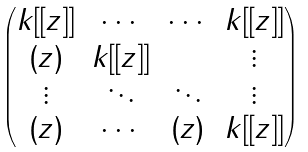Convert formula to latex. <formula><loc_0><loc_0><loc_500><loc_500>\begin{pmatrix} k [ [ z ] ] & \cdots & \cdots & k [ [ z ] ] \\ ( z ) & k [ [ z ] ] & & \vdots \\ \vdots & \ddots & \ddots & \vdots \\ ( z ) & \cdots & ( z ) & k [ [ z ] ] \end{pmatrix}</formula> 